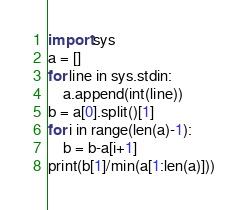<code> <loc_0><loc_0><loc_500><loc_500><_Python_>import sys
a = []
for line in sys.stdin:
    a.append(int(line))
b = a[0].split()[1]
for i in range(len(a)-1):
    b = b-a[i+1]
print(b[1]/min(a[1:len(a)]))</code> 